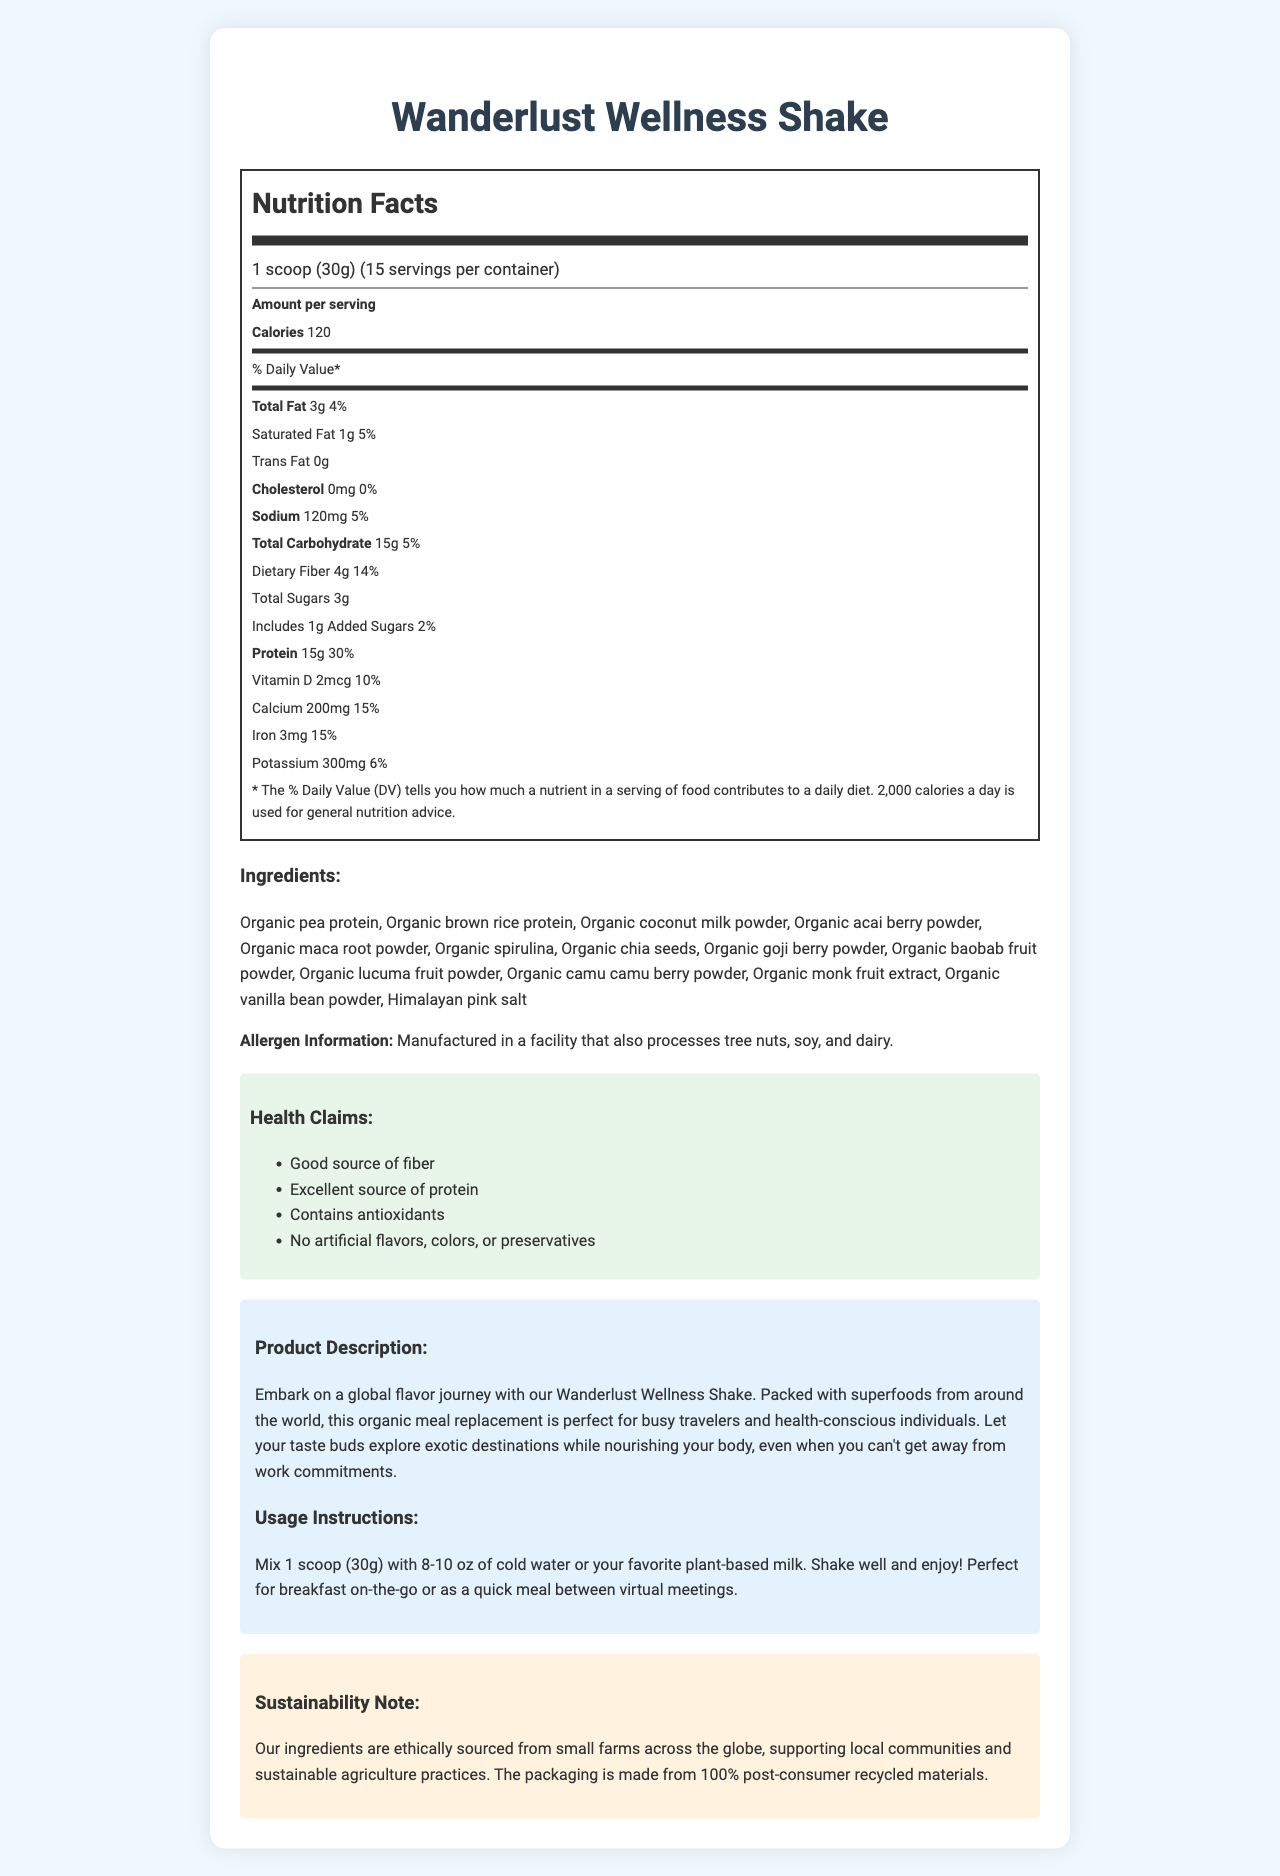what is the serving size of the Wanderlust Wellness Shake? The serving size is clearly stated at the beginning of the nutrition facts label.
Answer: 1 scoop (30g) how many calories are in one serving of Wanderlust Wellness Shake? The document specifies that one serving of the shake contains 120 calories.
Answer: 120 what is the total fat content per serving? The total fat content per serving is listed as 3g.
Answer: 3g how much dietary fiber is included in one serving and what is its daily value percentage? The dietary fiber content per serving is 4g, which represents 14% of the daily value.
Answer: 4g, 14% how much protein is provided per serving and what percentage of the daily value does this represent? Each serving of the shake provides 15g of protein, which corresponds to 30% of the daily value.
Answer: 15g, 30% which superfoods are included in the ingredients of the Wanderlust Wellness Shake? A. Organic acai berry powder B. Organic maca root powder C. Organic baobab fruit powder D. All of the above Organic acai berry powder, organic maca root powder, and organic baobab fruit powder are all listed among the superfood ingredients.
Answer: D. All of the above the Wanderlust Wellness Shake contains how much added sugar? A. 1g B. 3g C. 5g D. 10g The amount of added sugars per serving is noted as 1g.
Answer: A. 1g is this product manufactured in a facility that processes tree nuts? The allergen information states that the product is manufactured in a facility that also processes tree nuts.
Answer: Yes summarize the key features of the Wanderlust Wellness Shake. The Wanderlust Wellness Shake is an organic meal replacement shake packed with global superfoods. It is high in proteins and fibers while being low in added sugars. Additionally, it supports sustainability by using ethically sourced ingredients and recycled packaging materials.
Answer: This organic meal replacement shake, named Wanderlust Wellness Shake, offers a serving size of 1 scoop (30g) with 120 calories. It has notable superfoods including organic acai berry powder, organic maca root powder, and more. The shake is high in protein (15g, 30% DV) and fiber (4g, 14% DV), low in added sugars (1g), and includes various vitamins and minerals. It's manufactured in a facility that processes tree nuts, soy, and dairy. The product emphasizes sustainability and supports local farming practices. what are the health claims associated with the Wanderlust Wellness Shake? The health claims highlighted include being a good source of fiber, an excellent source of protein, containing antioxidants, and having no artificial flavors, colors, or preservatives.
Answer: Good source of fiber, Excellent source of protein, Contains antioxidants, No artificial flavors, colors, or preservatives what is the product description for the Wanderlust Wellness Shake? The description emphasizes the global superfood content, suitability for busy travelers and health-conscious individuals, and nourishment benefits despite work commitments.
Answer: Embark on a global flavor journey with our Wanderlust Wellness Shake. Packed with superfoods from around the world, this organic meal replacement is perfect for busy travelers and health-conscious individuals. Let your taste buds explore exotic destinations while nourishing your body, even when you can't get away from work commitments. can you find the type of plant-based milk recommended to mix with the shake? The document suggests mixing the shake with cold water or a favorite plant-based milk but doesn't specify which type of plant-based milk should be used.
Answer: Not enough information 